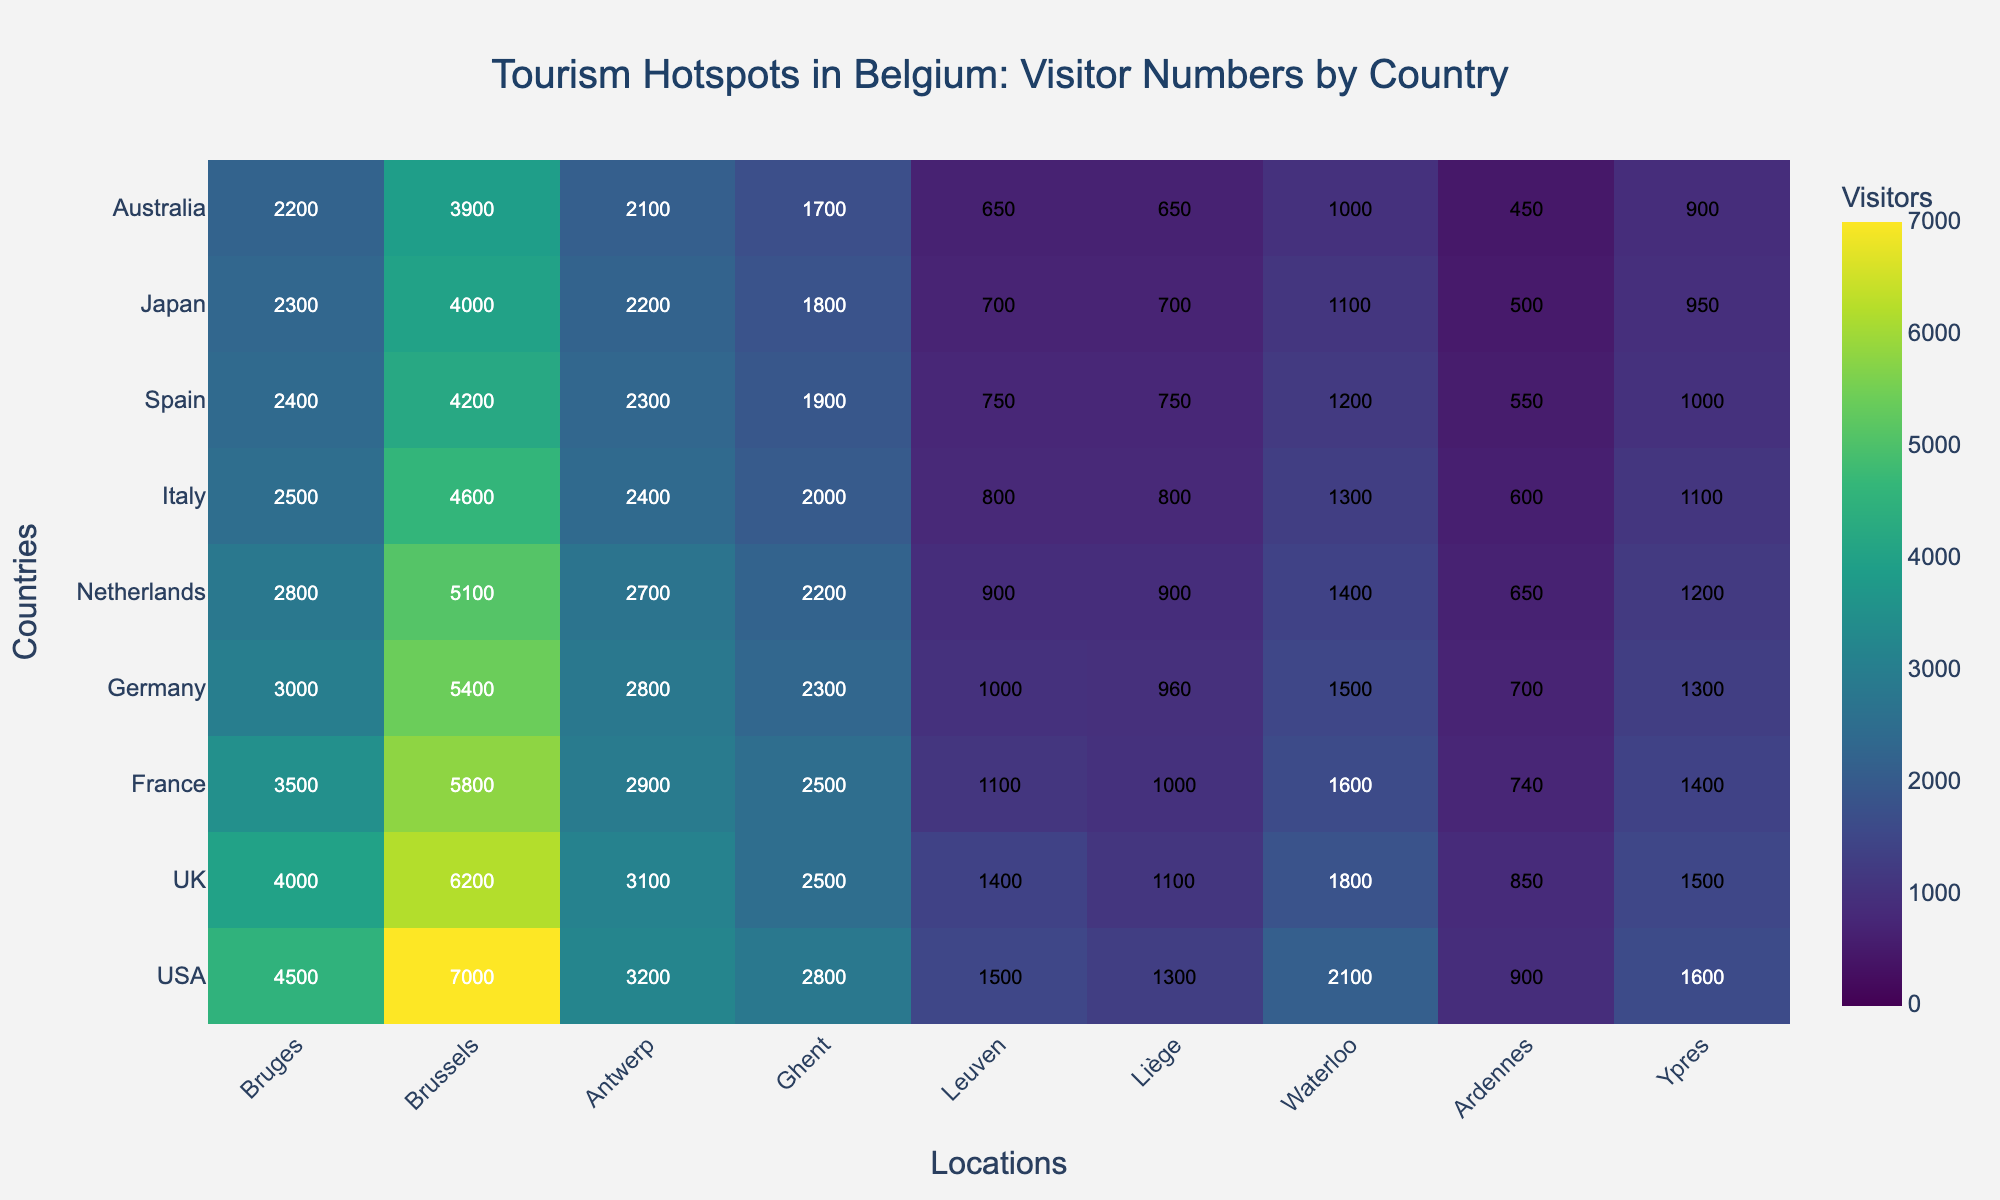Which location has the highest number of American visitors? The color intensity indicates that Brussels has the highest number of American visitors. The annotation shows 7000 for Brussels under USA.
Answer: Brussels How many visitors from the USA visited Antwerp and Ghent combined? Check the numbers under Antwerp and Ghent for the USA row: 3200 (Antwerp) + 2800 (Ghent).
Answer: 6000 Which country has the least visitors to Ypres? The color intensity and the annotation in the last column for Ypres show that Australia has the least visitors with 900.
Answer: Australia How does the number of American visitors to Leuven compare to those from Japan? Compare the numbers in the Leuven column for USA and Japan: 1500 (USA) vs. 700 (Japan). 1500 > 700.
Answer: USA has more What is the average number of visitors to Antwerp from all listed countries? Sum the numbers for Antwerp and divide by the number of countries: (3200 + 3100 + 2900 + 2800 + 2700 + 2400 + 2300 + 2200 + 2100)/9 = 2622.2.
Answer: 2622.2 Between the UK and France, which country has more visitors to Bruges? Compare the numbers for Bruges between the UK (4000) and France (3500). 4000 > 3500.
Answer: UK Which nationality has the closest number of visitors in Brussels and Liège? By comparing the visitor numbers, France has 5800 and 1000 in Brussels and Liège, respectively. The difference is 4800, which is smallest among other nationalities.
Answer: France What is the total number of visitors to Ghent from UK, France, and Germany combined? Sum the visitors to Ghent from these countries: 2500 (UK) + 2500 (France) + 2300 (Germany) = 7300.
Answer: 7300 Is the number of visitors from Spain to Leuven greater than the number of visitors from the Netherlands to Liège? Compare the visitors from Spain to Leuven (750) and from Netherlands to Liège (900). 750 < 900.
Answer: No What is the median number of visitors from Japan across all locations? List Japan’s visitors: 2300, 4000, 2200, 1800, 700, 700, 1100, 500, 950. Sorting: 500, 700, 700, 950, 1100, 1800, 2200, 2300, 4000. Median (5th value) is 1100.
Answer: 1100 